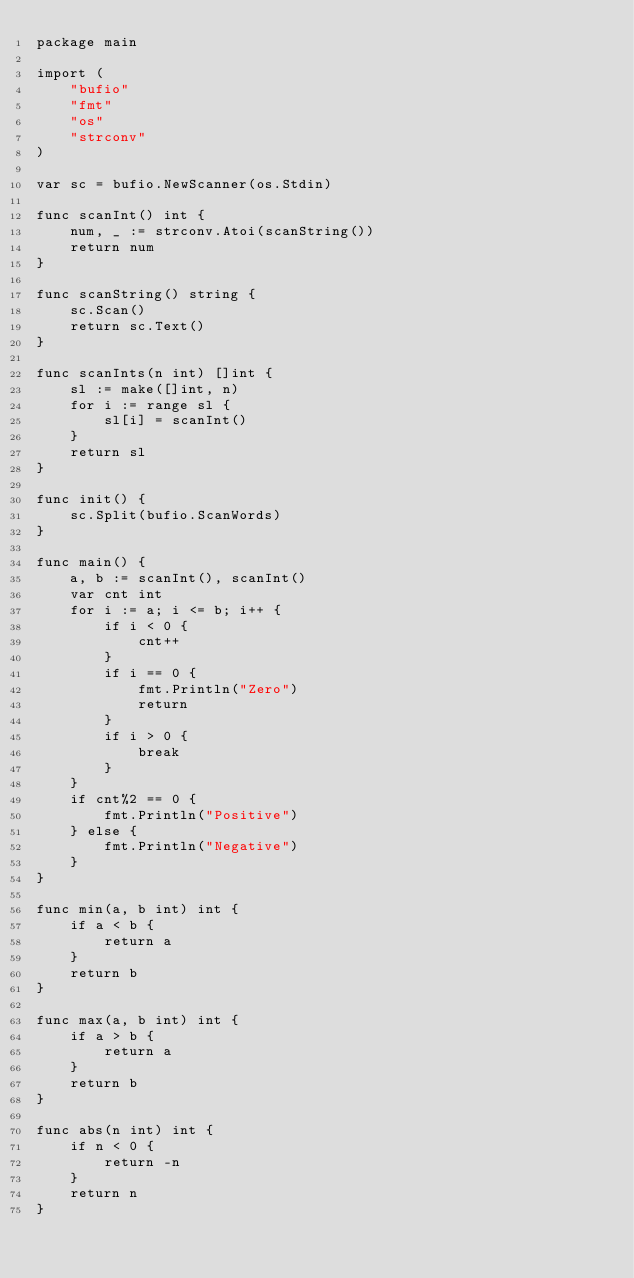Convert code to text. <code><loc_0><loc_0><loc_500><loc_500><_Go_>package main

import (
	"bufio"
	"fmt"
	"os"
	"strconv"
)

var sc = bufio.NewScanner(os.Stdin)

func scanInt() int {
	num, _ := strconv.Atoi(scanString())
	return num
}

func scanString() string {
	sc.Scan()
	return sc.Text()
}

func scanInts(n int) []int {
	sl := make([]int, n)
	for i := range sl {
		sl[i] = scanInt()
	}
	return sl
}

func init() {
	sc.Split(bufio.ScanWords)
}

func main() {
	a, b := scanInt(), scanInt()
	var cnt int
	for i := a; i <= b; i++ {
		if i < 0 {
			cnt++
		}
		if i == 0 {
			fmt.Println("Zero")
			return
		}
		if i > 0 {
			break
		}
	}
	if cnt%2 == 0 {
		fmt.Println("Positive")
	} else {
		fmt.Println("Negative")
	}
}

func min(a, b int) int {
	if a < b {
		return a
	}
	return b
}

func max(a, b int) int {
	if a > b {
		return a
	}
	return b
}

func abs(n int) int {
	if n < 0 {
		return -n
	}
	return n
}
</code> 